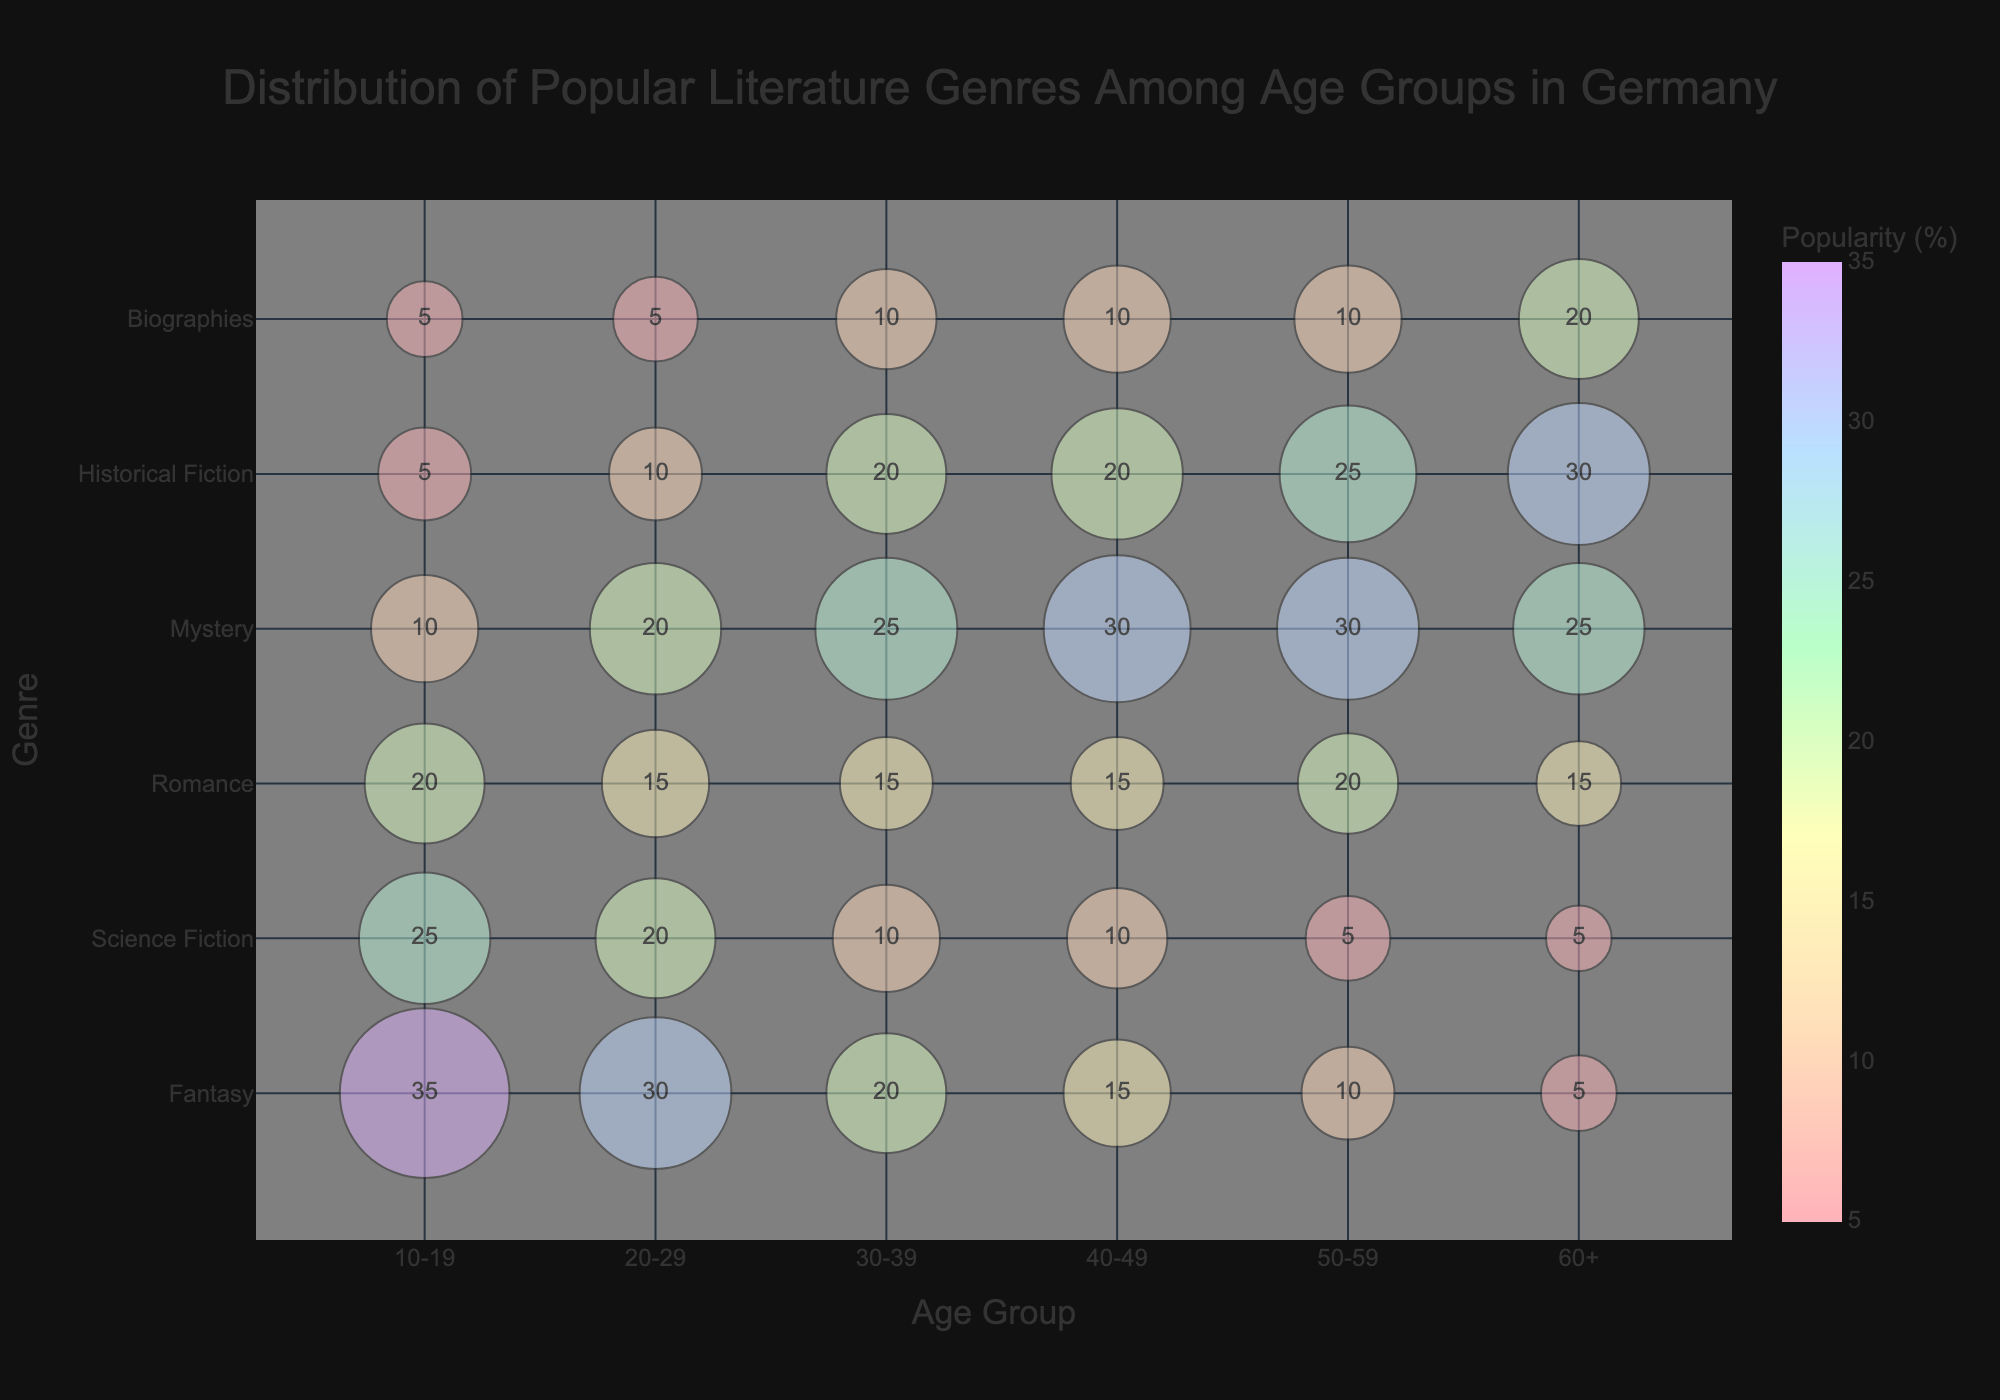What is the title of the Bubble Chart? The title of the chart is at the top of the figure, centered and written in a larger font. It reads "Distribution of Popular Literature Genres Among Age Groups in Germany".
Answer: Distribution of Popular Literature Genres Among Age Groups in Germany Which age group has the highest popularity for Fantasy literature? The chart displays the percentages of popularity for Fantasy across different age groups. The age group 10-19 has the highest popularity for Fantasy at 35%.
Answer: 10-19 How does the popularity of Science Fiction in the 20-29 age group compare to that in the 50-59 age group? To compare, we look at the percentages next to the Science Fiction bubbles for these age groups. The 20-29 age group has a 20% popularity, while the 50-59 age group has only 5%.
Answer: Greater What is the bubble size for Romance literature in the 30-39 age group? The bubble sizes are directly labeled on the figure next to each genre's bubble. For Romance in the age group 30-39, the size is 30.
Answer: 30 Which literature genre is most popular among the 60+ age group? By observing the percentages next to the bubbles in the 60+ age group, Historical Fiction has the highest percentage at 30%.
Answer: Historical Fiction How many genres have a higher popularity percentage in the 40-49 age group than in the 20-29 age group? We need to compare percentages between the age groups for each genre: Mystery (30% vs 20%), Historical Fiction (20% vs 10%), Biographies (10% vs 5%). That's 3 genres.
Answer: 3 What is the difference in popularity percentage for Mystery between the age groups 30-39 and 40-49? Check the percentages for Mystery in both age groups: 30-39 has 25%, and 40-49 has 30%. The difference is 30% - 25% = 5%.
Answer: 5% Which age group shows the least popularity for Biographies? Look at the percentages for Biographies across all age groups, the lowest percentage is 5% seen in both the 10-19 and 20-29 age groups.
Answer: 10-19 Is the popularity of Romance literature higher in the 50-59 age group or the 60+ age group? Compare the percentages for Romance in these age groups. The 50-59 age group has 20%, while the 60+ age group has 15%.
Answer: 50-59 Which genre has a similar popularity percentage across all age groups? By checking each genre's percentages across the age groups, we find that Biographies have relatively similar values of 5%-20% across all ages.
Answer: Biographies 